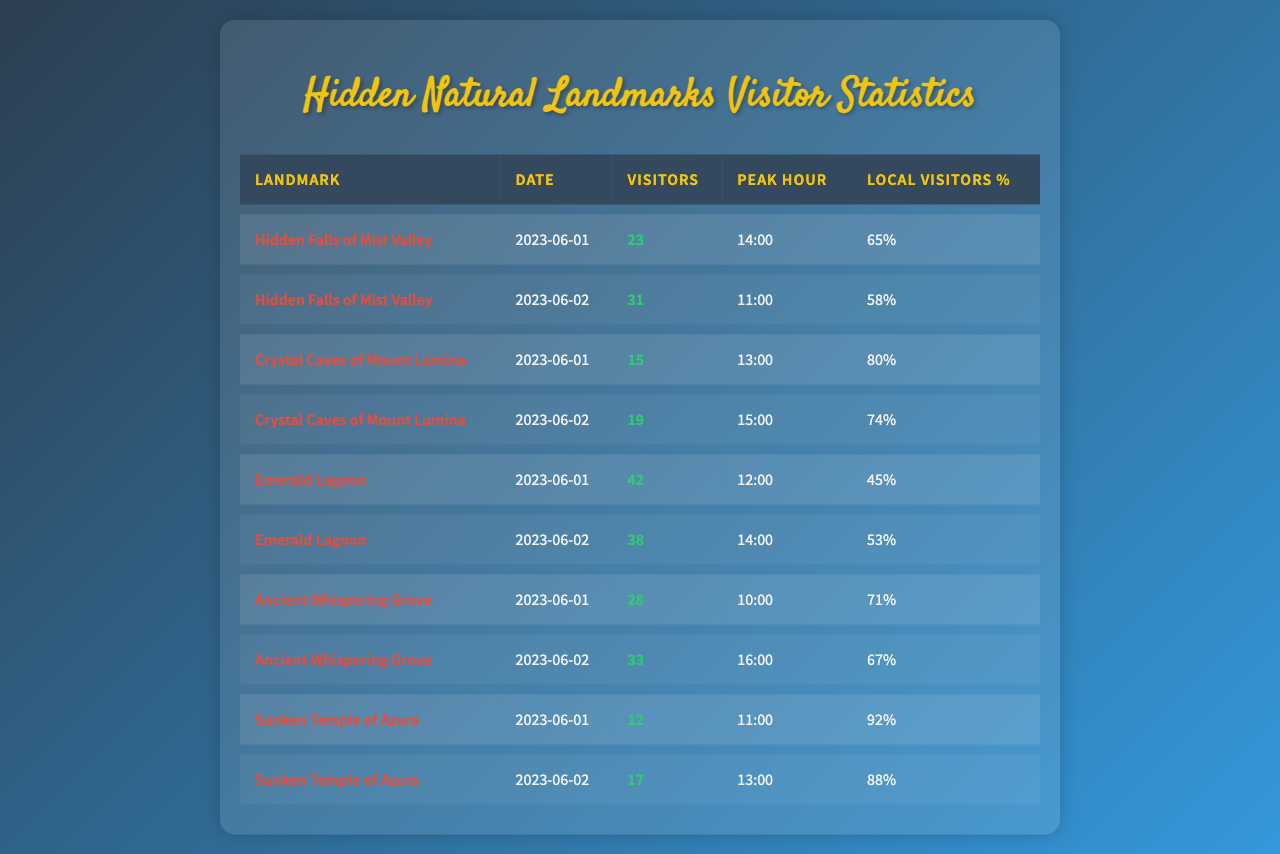What was the peak hour for the Hidden Falls of Mist Valley on June 1, 2023? The table shows the peak hour for the Hidden Falls of Mist Valley on June 1, 2023, as 14:00.
Answer: 14:00 How many visitors did the Crystal Caves of Mount Lumina receive on June 2, 2023? Referring to the table, the Crystal Caves of Mount Lumina had 19 visitors on June 2, 2023.
Answer: 19 What percentage of visitors to the Sunken Temple of Azura on June 1, 2023, were local? According to the data, the local visitors percentage for the Sunken Temple of Azura on June 1, 2023, was 92%.
Answer: 92% Which landmark had the most visitors on June 1, 2023? Looking at the visitors on June 1, 2023, Emerald Lagoon had the most with 42 visitors, compared to other landmarks.
Answer: Emerald Lagoon What is the average number of visitors for the Ancient Whispering Grove across the two days? The number of visitors for the Ancient Whispering Grove on June 1 was 28 and on June 2 was 33. Adding these gives 28 + 33 = 61. There are 2 days, thus the average is 61 / 2 = 30.5.
Answer: 30.5 Did more visitors come to the Emerald Lagoon on June 1 than the Crystal Caves of Mount Lumina on the same day? The Emerald Lagoon had 42 visitors on June 1, while the Crystal Caves of Mount Lumina had 15 visitors, hence more visitors came to the Emerald Lagoon.
Answer: Yes On which date did the landmark with the highest percentage of local visitors have that percentage? The highest local visitors percentage was 92% for the Sunken Temple of Azura on June 1, 2023, as shown in the table.
Answer: June 1, 2023 What is the total number of visitors to the Hidden Falls of Mist Valley over the two days? Summing the visitors for Hidden Falls of Mist Valley on June 1 (23) and June 2 (31) gives a total of 23 + 31 = 54 visitors.
Answer: 54 Which landmark had the lowest percentage of local visitors on June 2, 2023? On June 2, the Emerald Lagoon had the lowest percentage of local visitors at 53% among all landmarks listed.
Answer: Emerald Lagoon If we compare the peak hours of the two days for the Ancient Whispering Grove, what is the time difference? The peak hour for Ancient Whispering Grove on June 1 was at 10:00 and on June 2 was at 16:00. Converting to 24-hour time format, the difference is 16 - 10 = 6 hours.
Answer: 6 hours 